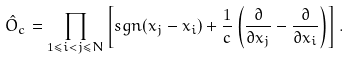Convert formula to latex. <formula><loc_0><loc_0><loc_500><loc_500>\hat { O } _ { c } = \prod _ { 1 \leq i < j \leq N } \left [ s g n ( x _ { j } - x _ { i } ) + \frac { 1 } { c } \left ( \frac { \partial } { \partial x _ { j } } - \frac { \partial } { \partial x _ { i } } \right ) \right ] .</formula> 